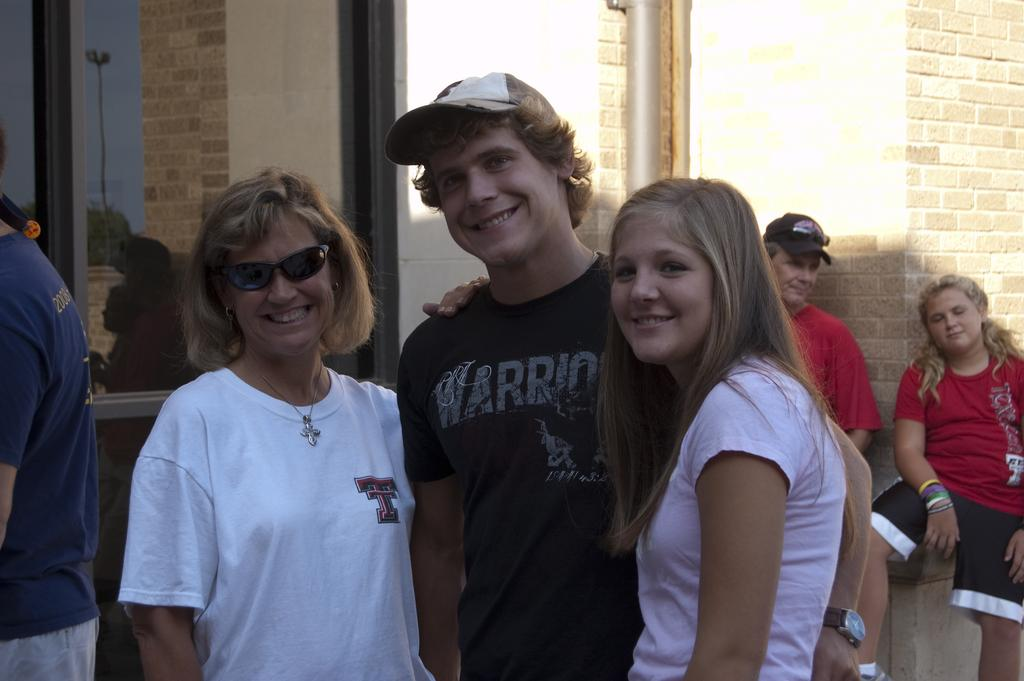What can be seen in the image involving people? There are people standing in the image. What is the background of the image? There is a wall in the image. What type of windows are present in the image? There are glass windows in the image. What can be seen through the glass windows? Trees and the sky are visible through the glass windows. What committee is responsible for the floor in the image? There is no mention of a floor or a committee in the image. 